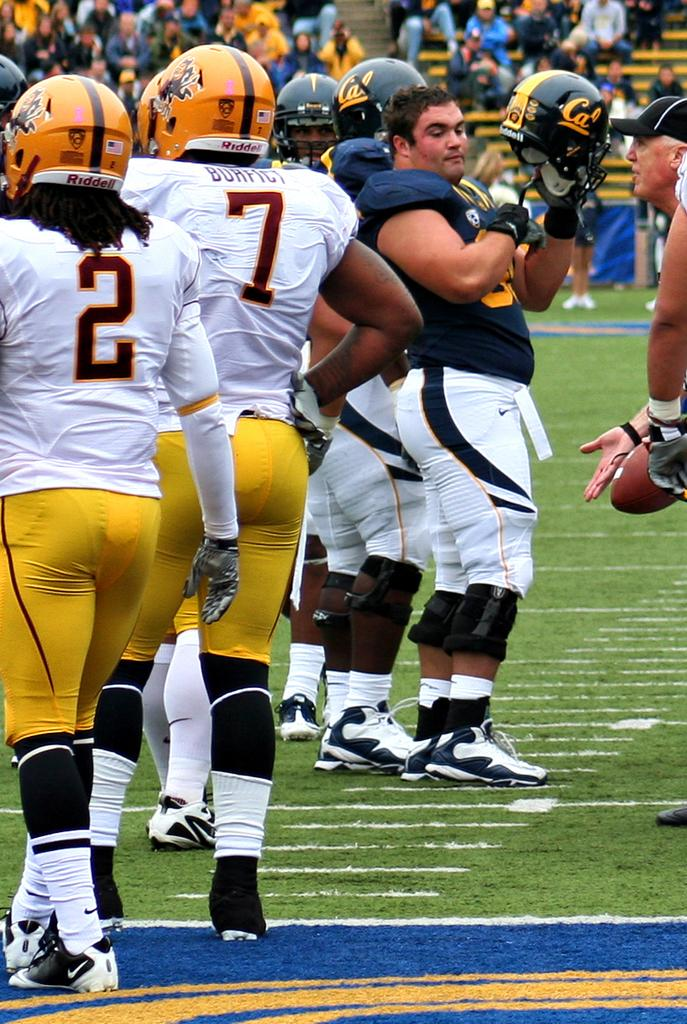What is the surface that the persons are standing on in the image? The ground is covered with grass. What can be seen in the background of the image? There is a crowd visible in the background. How many people are present in the image? There are persons on the ground, but the exact number cannot be determined from the provided facts. What type of house is visible in the image? There is no house present in the image; it features persons on the ground and a crowd in the background. How does the crowd express regret in the image? There is no indication in the image that the crowd is expressing regret, as their emotions or actions are not described in the provided facts. 